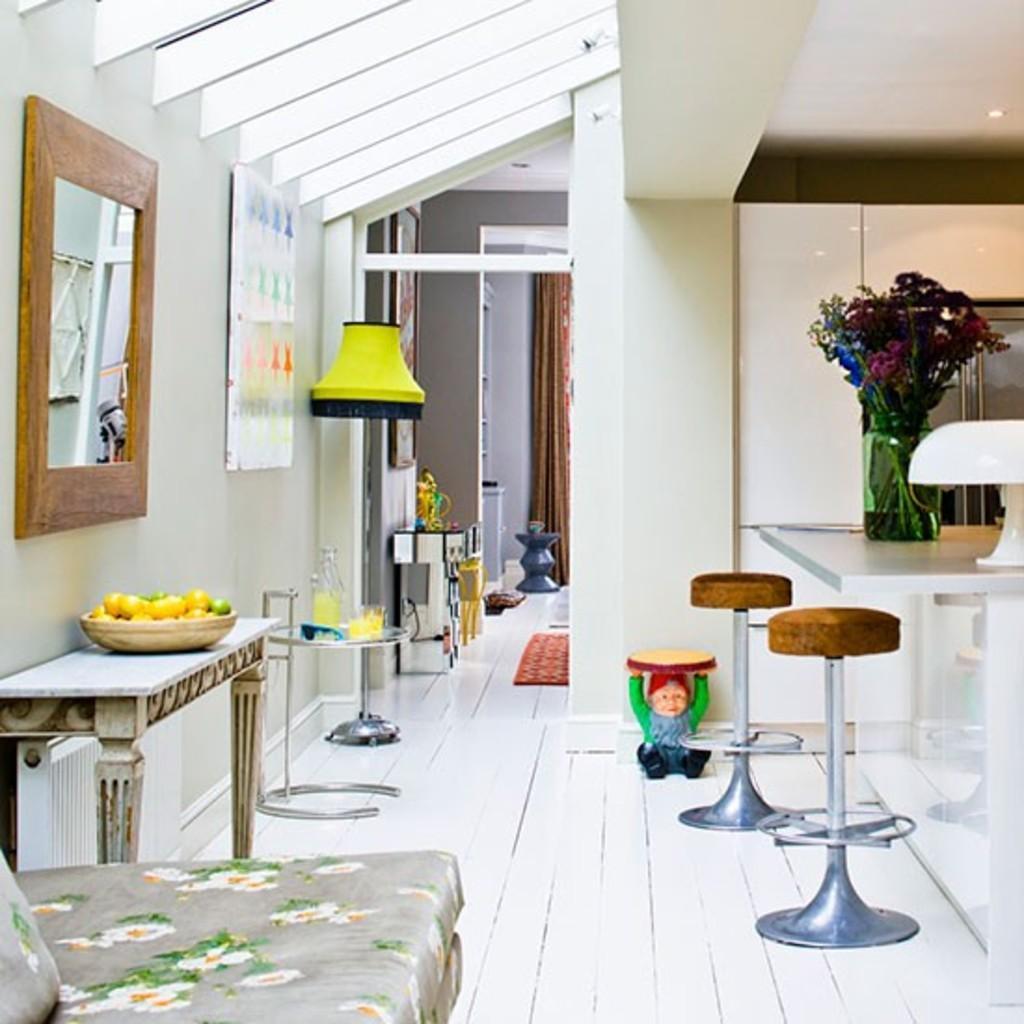How would you summarize this image in a sentence or two? This picture shows mirror on the wall and we see a table with some fruits in the basket and we see a flower pot and couple of stools and we see a frame on the wall and a stand light and we see a bed on the side and a mat on the floor and we see a curtain. 